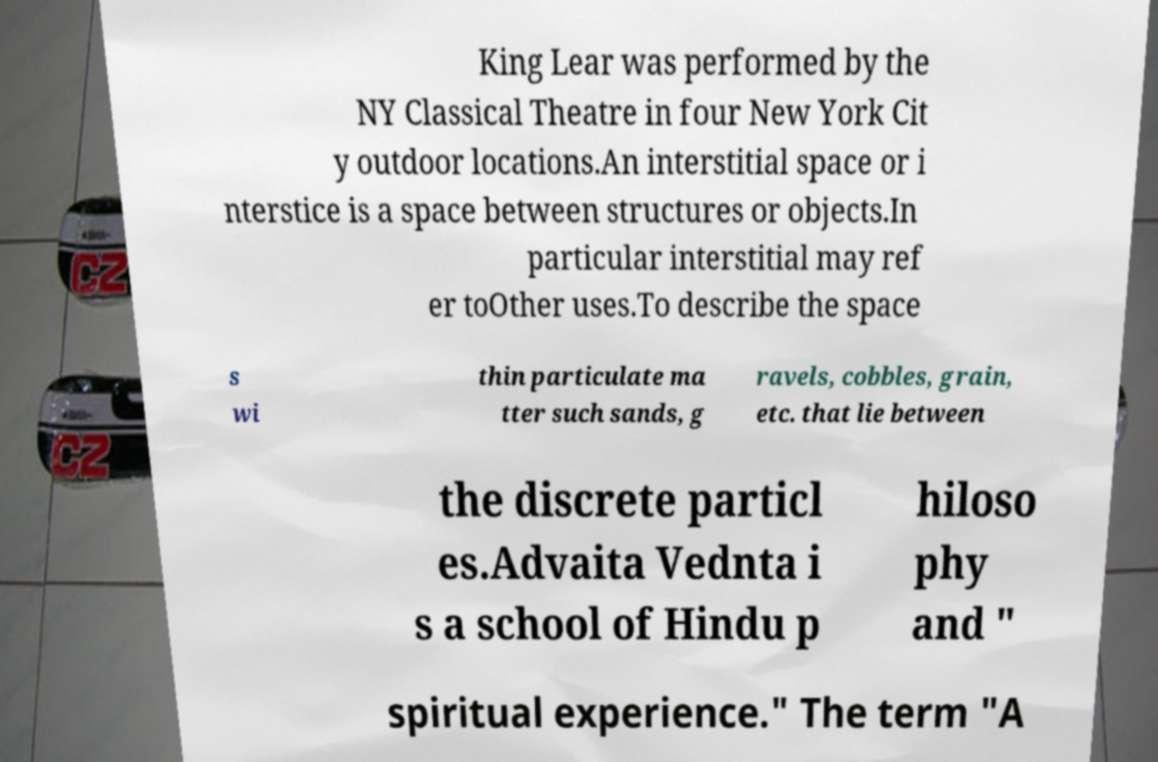Can you accurately transcribe the text from the provided image for me? King Lear was performed by the NY Classical Theatre in four New York Cit y outdoor locations.An interstitial space or i nterstice is a space between structures or objects.In particular interstitial may ref er toOther uses.To describe the space s wi thin particulate ma tter such sands, g ravels, cobbles, grain, etc. that lie between the discrete particl es.Advaita Vednta i s a school of Hindu p hiloso phy and " spiritual experience." The term "A 